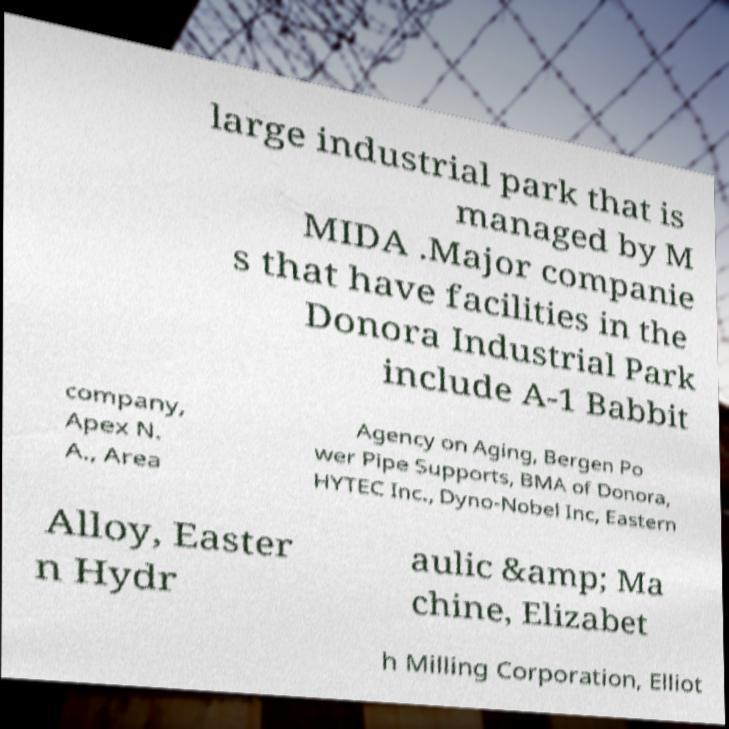Can you read and provide the text displayed in the image?This photo seems to have some interesting text. Can you extract and type it out for me? large industrial park that is managed by M MIDA .Major companie s that have facilities in the Donora Industrial Park include A-1 Babbit company, Apex N. A., Area Agency on Aging, Bergen Po wer Pipe Supports, BMA of Donora, HYTEC Inc., Dyno-Nobel Inc, Eastern Alloy, Easter n Hydr aulic &amp; Ma chine, Elizabet h Milling Corporation, Elliot 